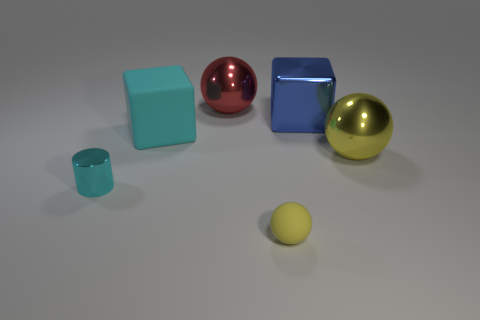Add 3 cyan cubes. How many objects exist? 9 Subtract all large shiny balls. How many balls are left? 1 Subtract all yellow spheres. How many spheres are left? 1 Subtract 1 cubes. How many cubes are left? 1 Subtract all cubes. How many objects are left? 4 Subtract all brown blocks. How many red balls are left? 1 Subtract 0 gray balls. How many objects are left? 6 Subtract all cyan blocks. Subtract all gray cylinders. How many blocks are left? 1 Subtract all yellow rubber objects. Subtract all small cyan metal cylinders. How many objects are left? 4 Add 5 red objects. How many red objects are left? 6 